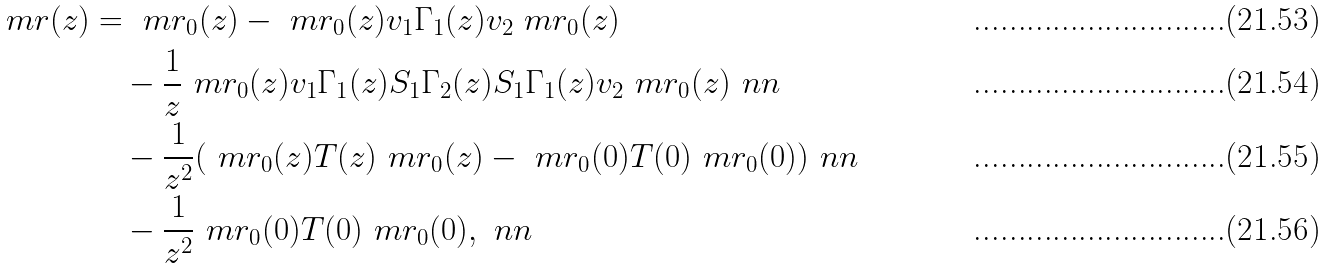<formula> <loc_0><loc_0><loc_500><loc_500>\ m r ( z ) & = \ m r _ { 0 } ( z ) - \ m r _ { 0 } ( z ) v _ { 1 } \Gamma _ { 1 } ( z ) v _ { 2 } \ m r _ { 0 } ( z ) \\ & \quad - \frac { 1 } { z } \ m r _ { 0 } ( z ) v _ { 1 } \Gamma _ { 1 } ( z ) S _ { 1 } \Gamma _ { 2 } ( z ) S _ { 1 } \Gamma _ { 1 } ( z ) v _ { 2 } \ m r _ { 0 } ( z ) \ n n \\ & \quad - \frac { 1 } { z ^ { 2 } } ( \ m r _ { 0 } ( z ) T ( z ) \ m r _ { 0 } ( z ) - \ m r _ { 0 } ( 0 ) T ( 0 ) \ m r _ { 0 } ( 0 ) ) \ n n \\ & \quad - \frac { 1 } { z ^ { 2 } } \ m r _ { 0 } ( 0 ) T ( 0 ) \ m r _ { 0 } ( 0 ) , \ n n</formula> 